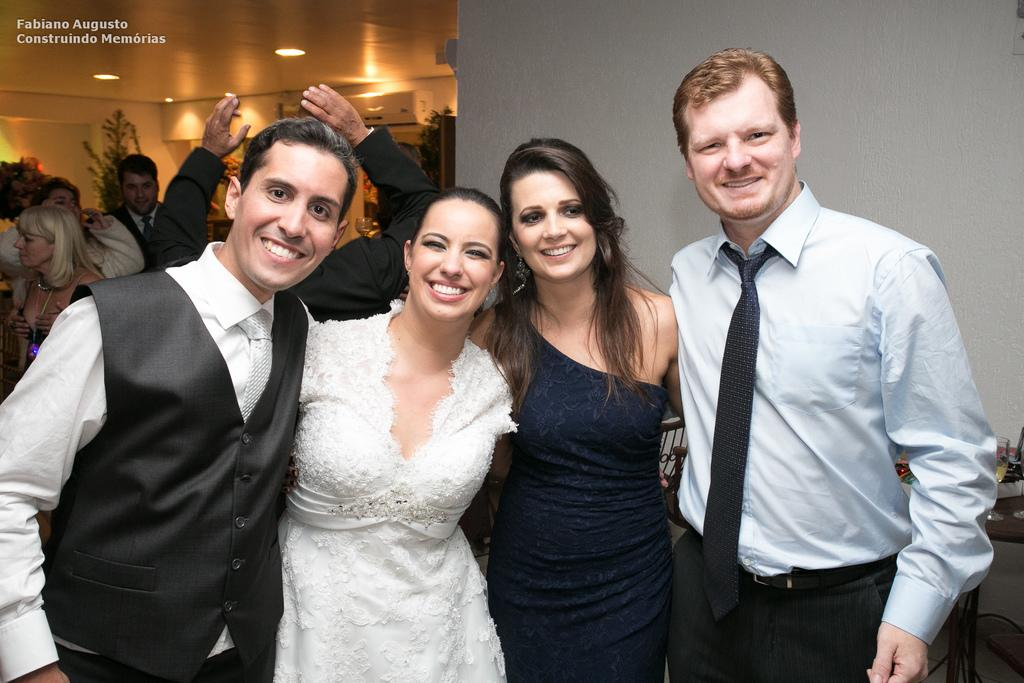How many people can be seen in the image? There are people in the image, but the exact number is not specified. Can you describe the background of the image? The background of the image includes plants, a wall, lights, and other objects. Are there any people in the background of the image? Yes, there are people in the background of the image. What is the purpose of the lights in the background? The purpose of the lights in the background is not specified in the given facts. What is the watermark on the image? The watermark on the image is not described in the given facts. What type of coach is present in the image? There is no coach present in the image. What is the topic of the meeting taking place in the image? There is no meeting taking place in the image. 